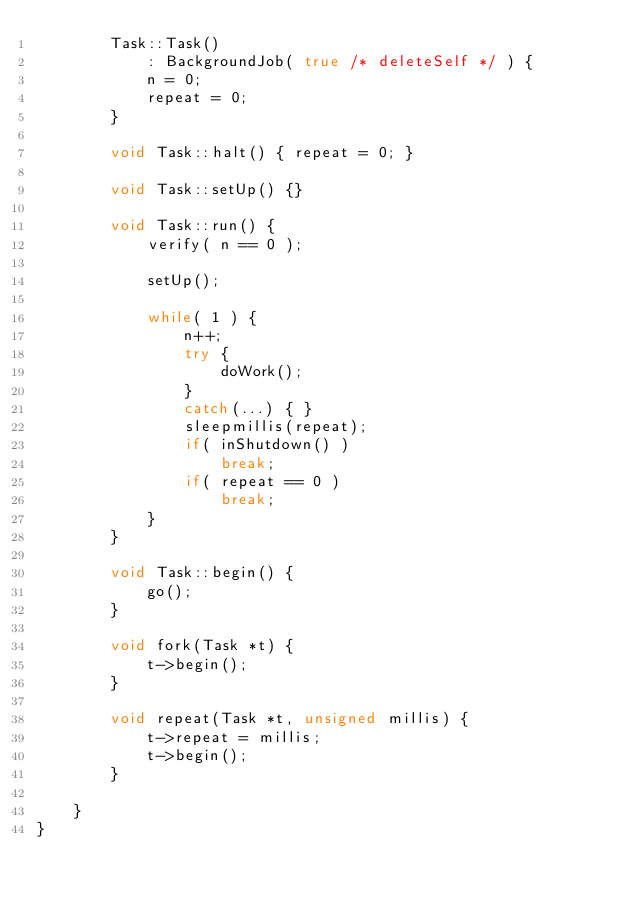Convert code to text. <code><loc_0><loc_0><loc_500><loc_500><_C++_>        Task::Task()
            : BackgroundJob( true /* deleteSelf */ ) {
            n = 0;
            repeat = 0;
        }

        void Task::halt() { repeat = 0; }

        void Task::setUp() {}

        void Task::run() {
            verify( n == 0 );

            setUp();

            while( 1 ) {
                n++;
                try {
                    doWork();
                }
                catch(...) { }
                sleepmillis(repeat);
                if( inShutdown() )
                    break;
                if( repeat == 0 )
                    break;
            }
        }

        void Task::begin() {
            go();
        }

        void fork(Task *t) {
            t->begin();
        }

        void repeat(Task *t, unsigned millis) {
            t->repeat = millis;
            t->begin();
        }

    }
}
</code> 